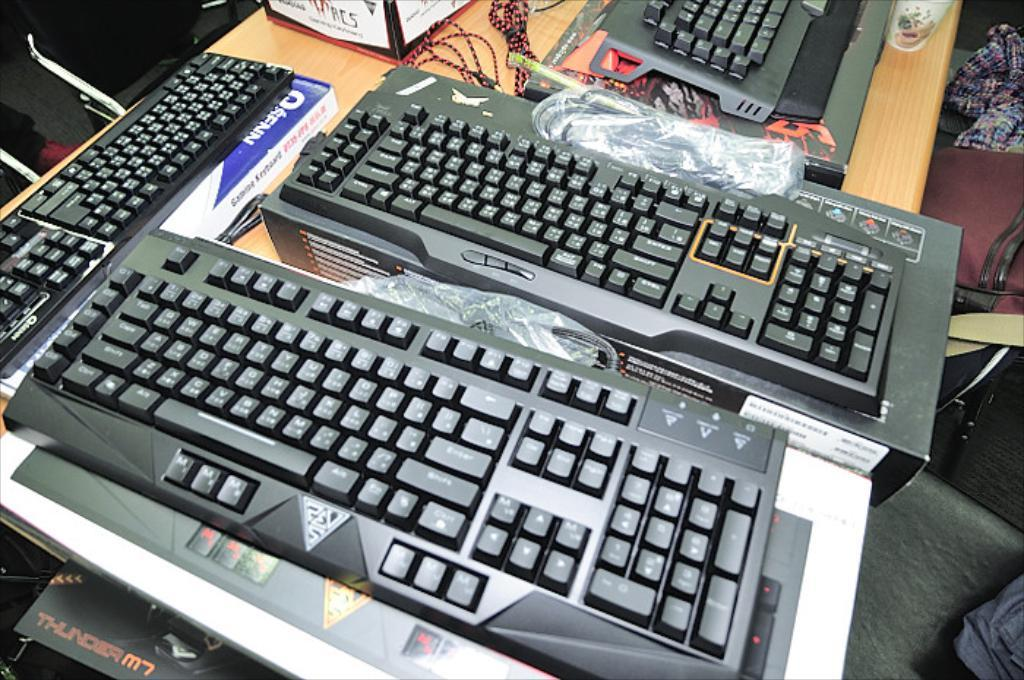<image>
Summarize the visual content of the image. A black corner of a box that reads Thunder M7 peeks under a desk to the left with keyboards. 